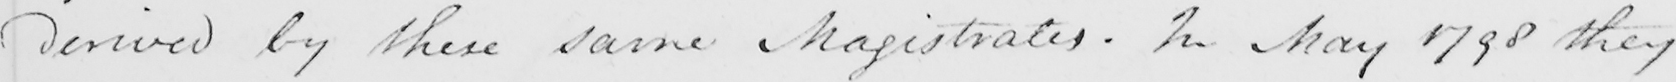Please provide the text content of this handwritten line. derived by these same Magistrates . In May 1798 they 